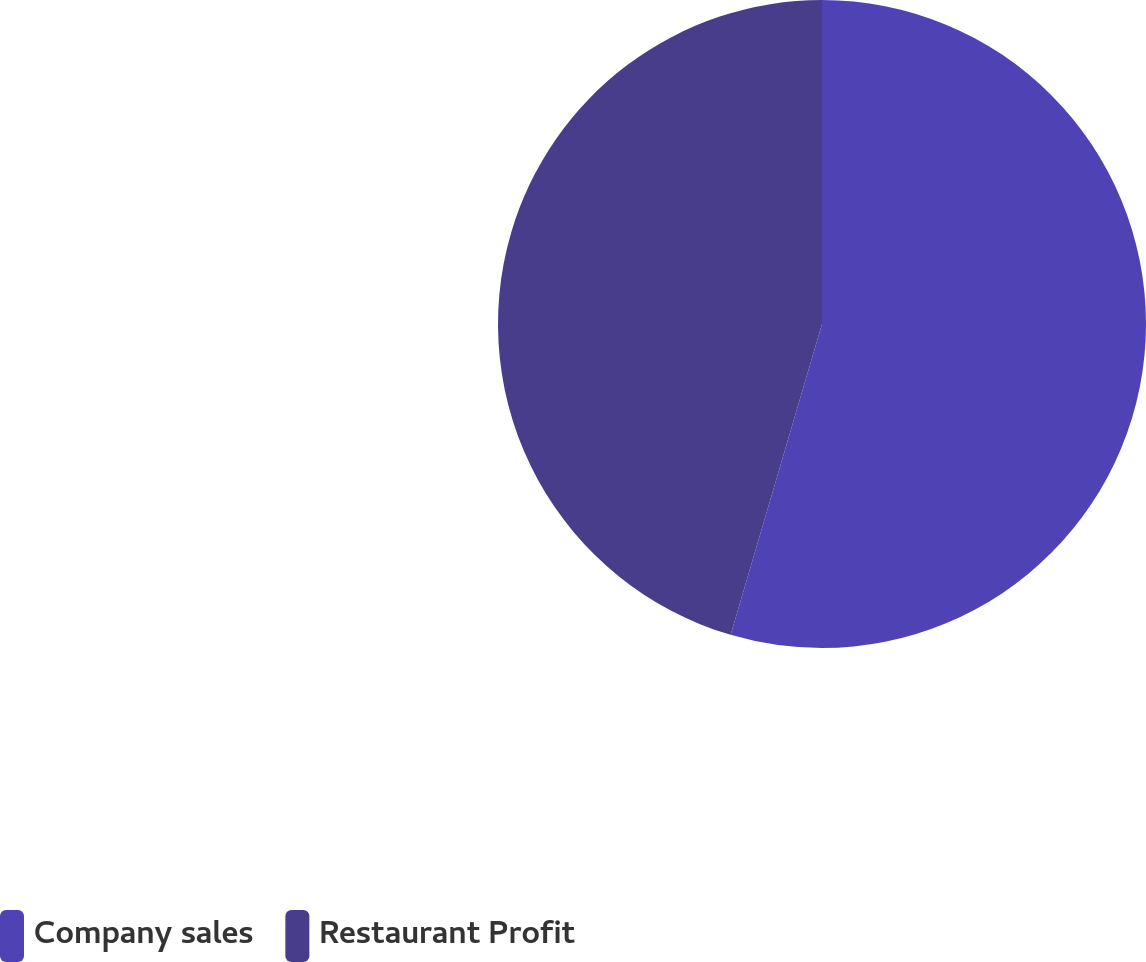<chart> <loc_0><loc_0><loc_500><loc_500><pie_chart><fcel>Company sales<fcel>Restaurant Profit<nl><fcel>54.55%<fcel>45.45%<nl></chart> 